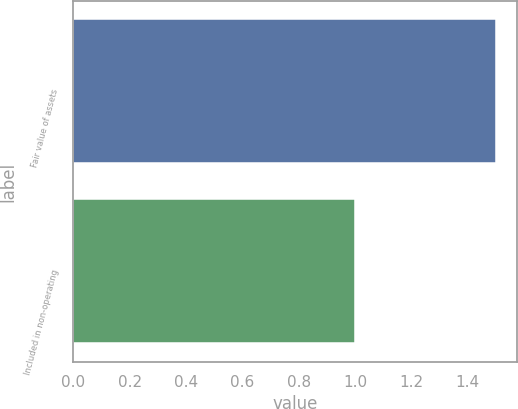<chart> <loc_0><loc_0><loc_500><loc_500><bar_chart><fcel>Fair value of assets<fcel>Included in non-operating<nl><fcel>1.5<fcel>1<nl></chart> 